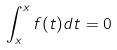Convert formula to latex. <formula><loc_0><loc_0><loc_500><loc_500>\int _ { x } ^ { x } f ( t ) d t = 0</formula> 